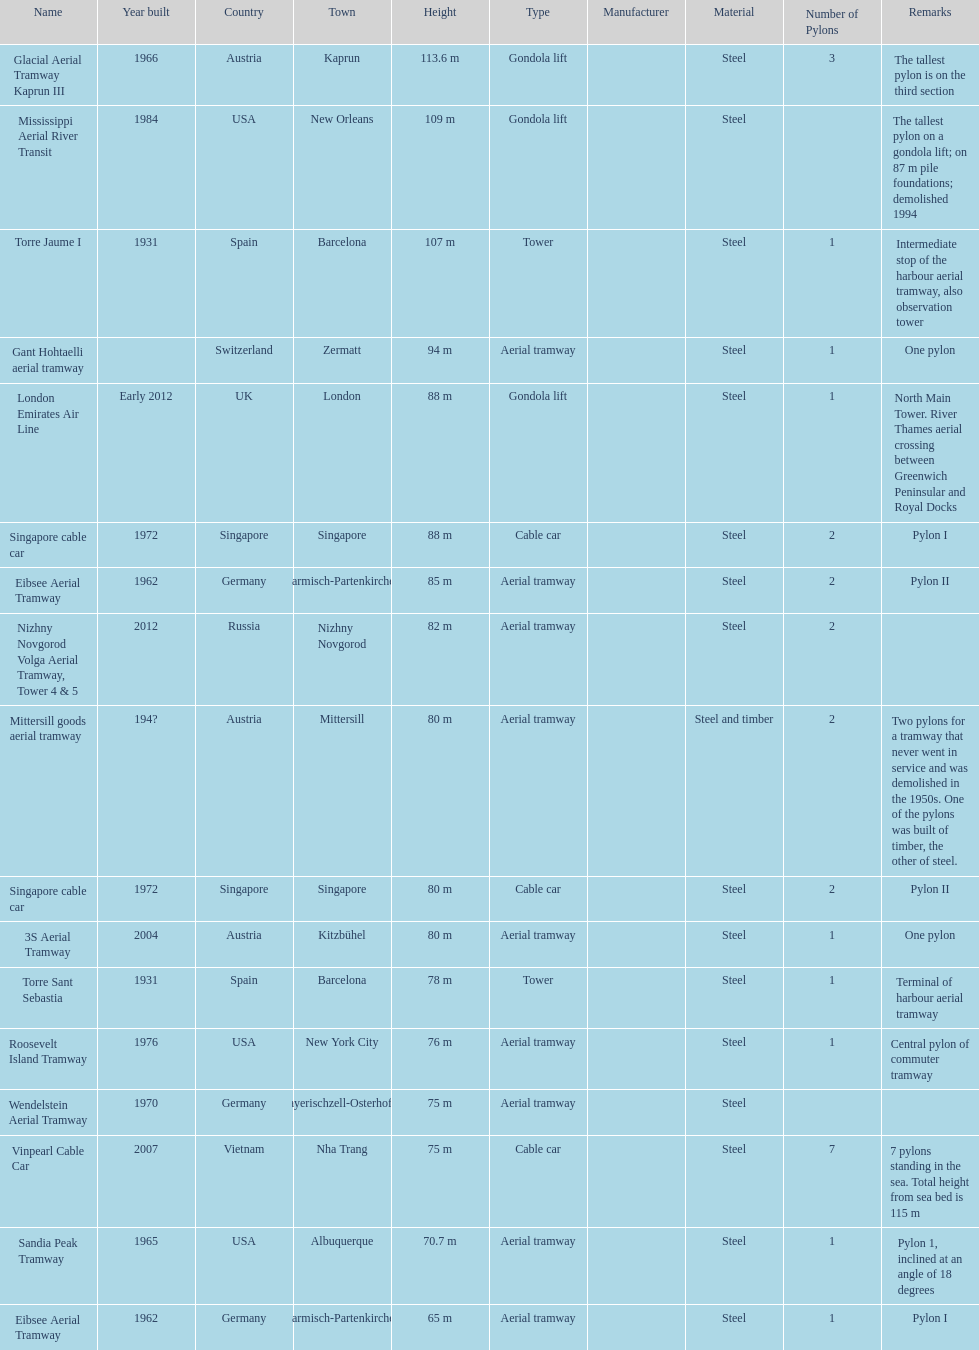What year was the last pylon in germany built? 1970. 